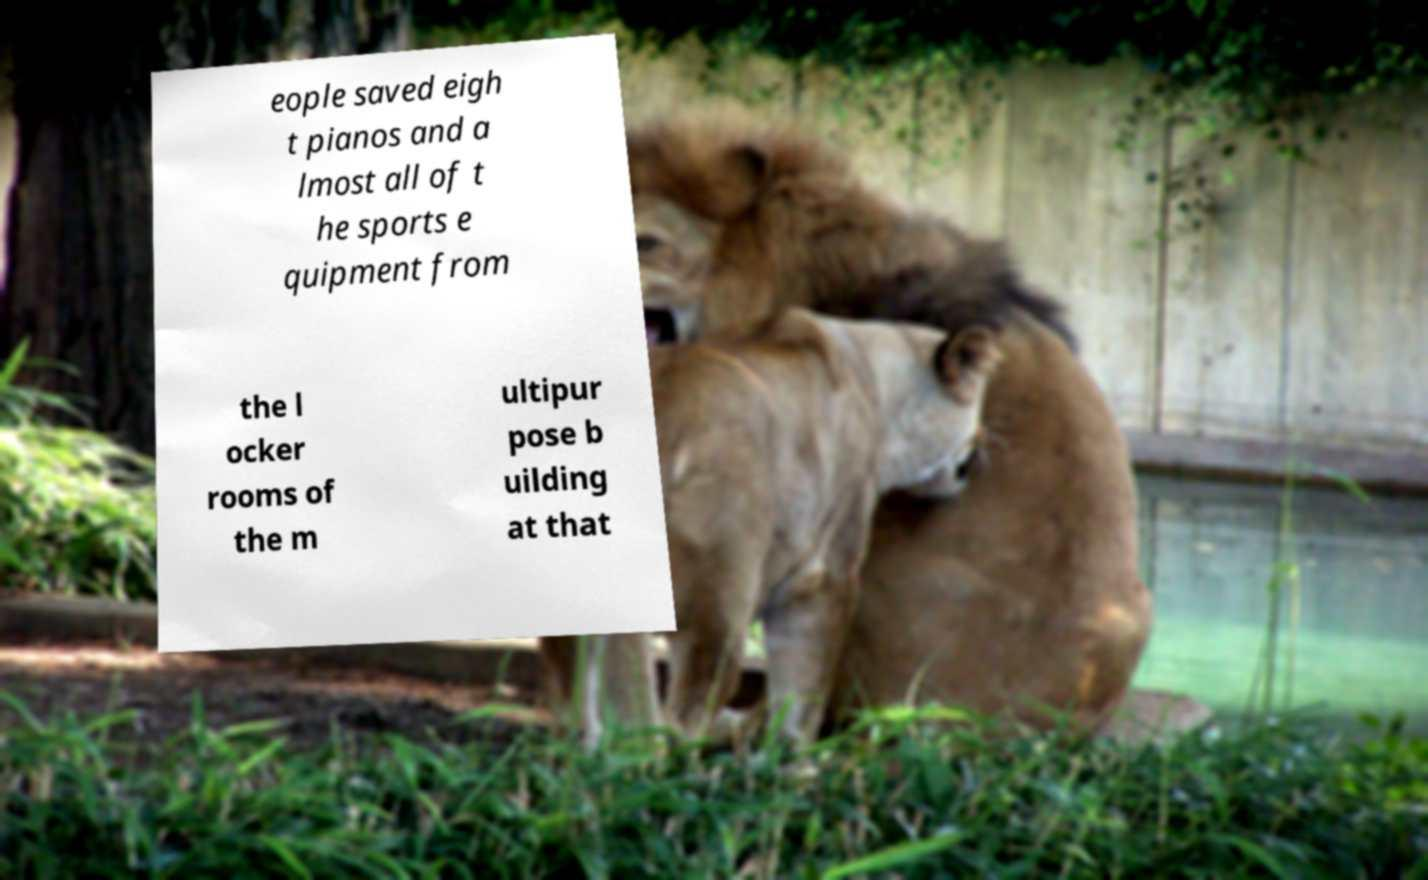Can you read and provide the text displayed in the image?This photo seems to have some interesting text. Can you extract and type it out for me? eople saved eigh t pianos and a lmost all of t he sports e quipment from the l ocker rooms of the m ultipur pose b uilding at that 